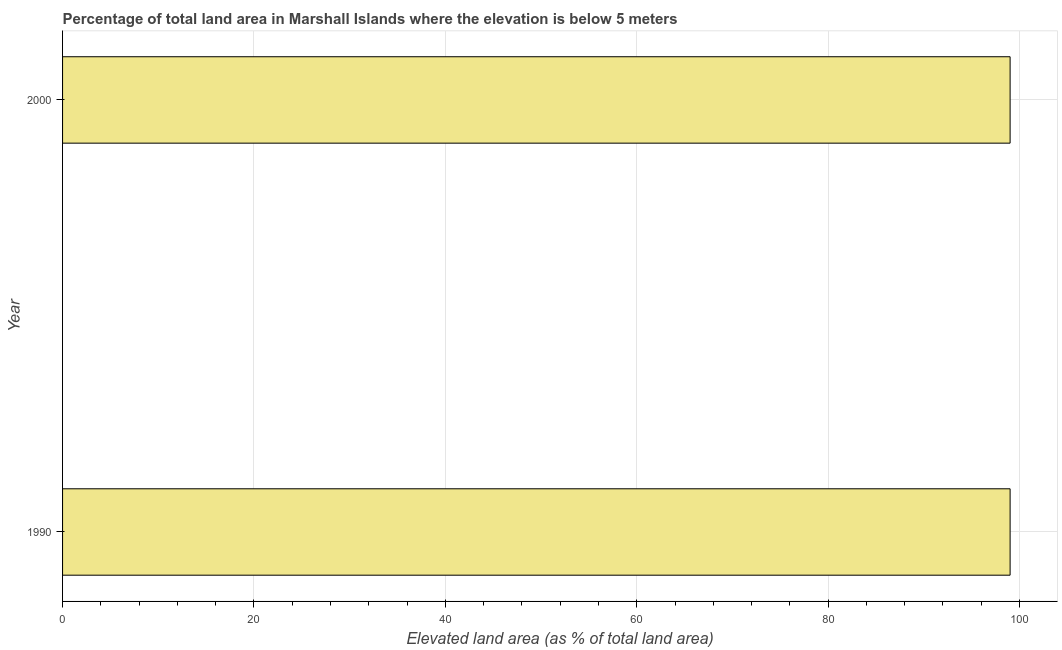Does the graph contain any zero values?
Make the answer very short. No. Does the graph contain grids?
Offer a very short reply. Yes. What is the title of the graph?
Provide a succinct answer. Percentage of total land area in Marshall Islands where the elevation is below 5 meters. What is the label or title of the X-axis?
Your answer should be compact. Elevated land area (as % of total land area). What is the label or title of the Y-axis?
Your answer should be very brief. Year. What is the total elevated land area in 1990?
Your response must be concise. 99.02. Across all years, what is the maximum total elevated land area?
Provide a short and direct response. 99.02. Across all years, what is the minimum total elevated land area?
Make the answer very short. 99.02. In which year was the total elevated land area maximum?
Ensure brevity in your answer.  1990. What is the sum of the total elevated land area?
Provide a short and direct response. 198.04. What is the difference between the total elevated land area in 1990 and 2000?
Your response must be concise. 0. What is the average total elevated land area per year?
Your response must be concise. 99.02. What is the median total elevated land area?
Give a very brief answer. 99.02. In how many years, is the total elevated land area greater than 72 %?
Provide a succinct answer. 2. What is the ratio of the total elevated land area in 1990 to that in 2000?
Your response must be concise. 1. What is the difference between two consecutive major ticks on the X-axis?
Your response must be concise. 20. Are the values on the major ticks of X-axis written in scientific E-notation?
Give a very brief answer. No. What is the Elevated land area (as % of total land area) in 1990?
Give a very brief answer. 99.02. What is the Elevated land area (as % of total land area) in 2000?
Make the answer very short. 99.02. What is the difference between the Elevated land area (as % of total land area) in 1990 and 2000?
Give a very brief answer. 0. 